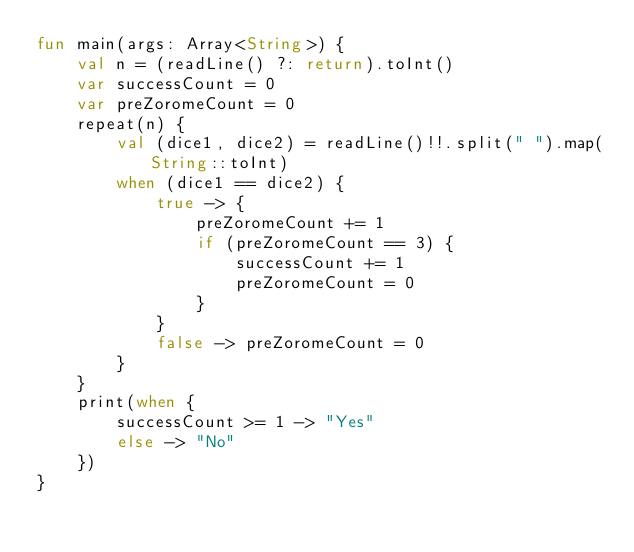<code> <loc_0><loc_0><loc_500><loc_500><_Kotlin_>fun main(args: Array<String>) {
    val n = (readLine() ?: return).toInt()
    var successCount = 0
    var preZoromeCount = 0
    repeat(n) {
        val (dice1, dice2) = readLine()!!.split(" ").map(String::toInt)
        when (dice1 == dice2) {
            true -> {
                preZoromeCount += 1
                if (preZoromeCount == 3) {
                    successCount += 1
                    preZoromeCount = 0
                }
            }
            false -> preZoromeCount = 0
        }
    }
    print(when {
        successCount >= 1 -> "Yes"
        else -> "No"
    })
}</code> 